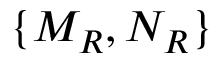Convert formula to latex. <formula><loc_0><loc_0><loc_500><loc_500>\{ M _ { R } , N _ { R } \}</formula> 